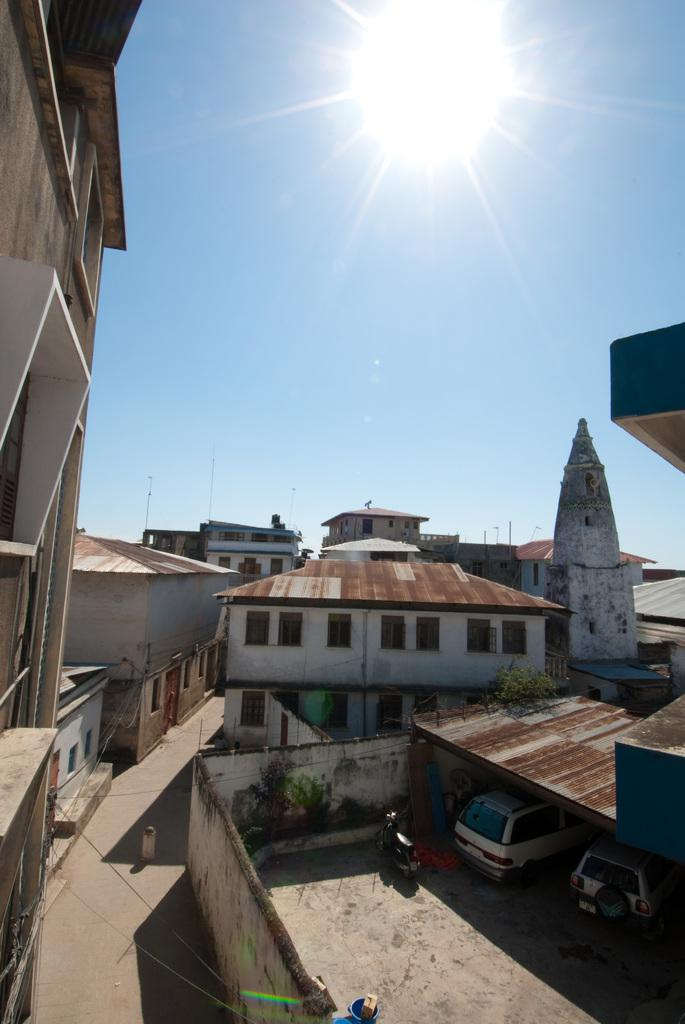What type of structures can be seen in the image? There are buildings in the image. What else is present in the image besides buildings? There are vehicles and a fence wall visible in the image. What can be seen in the background of the image? The sun and the sky are visible in the background of the image. How many servants are attending to the vehicles in the image? There are no servants present in the image; it only features buildings, vehicles, and a fence wall. What type of rake is being used to maintain the grass in the image? There is no rake visible in the image, as it does not show any grass or gardening activities. 